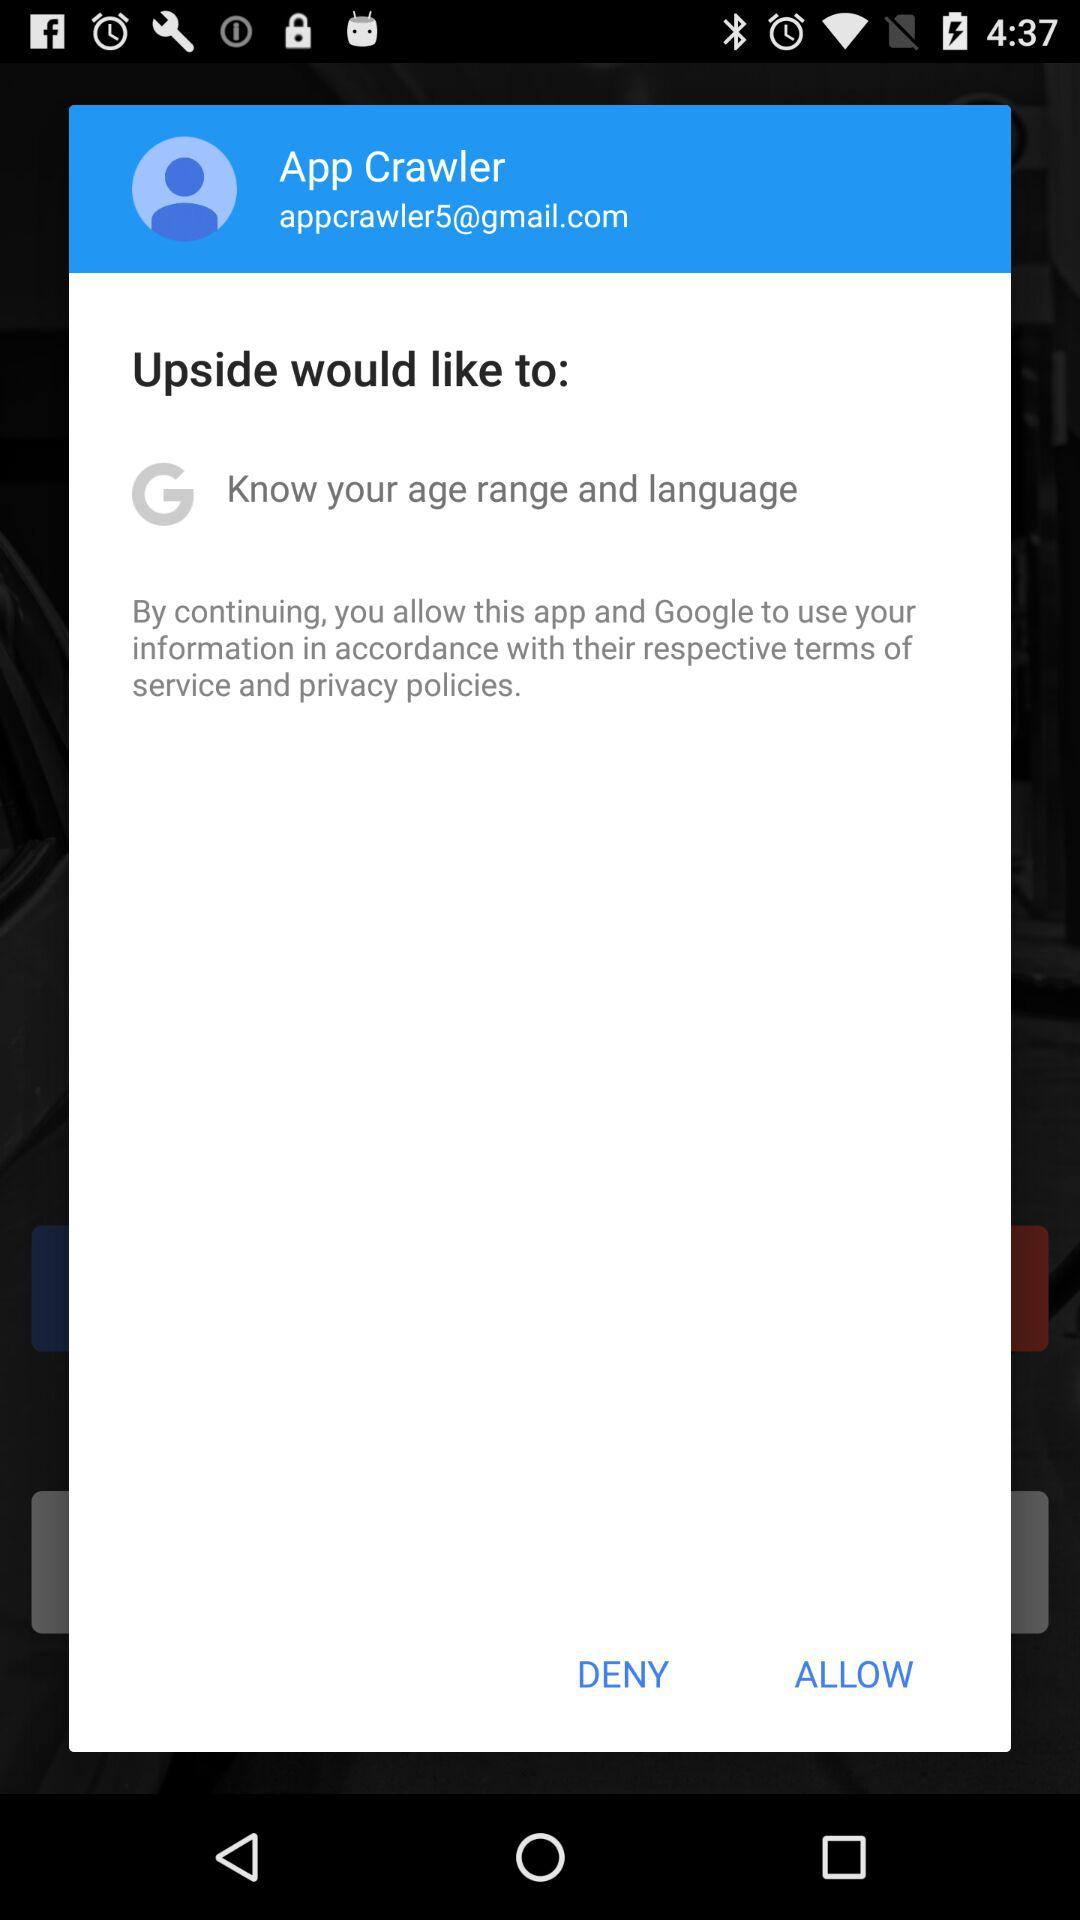What is the email address? The email address is appcrawler5@gmail.com. 